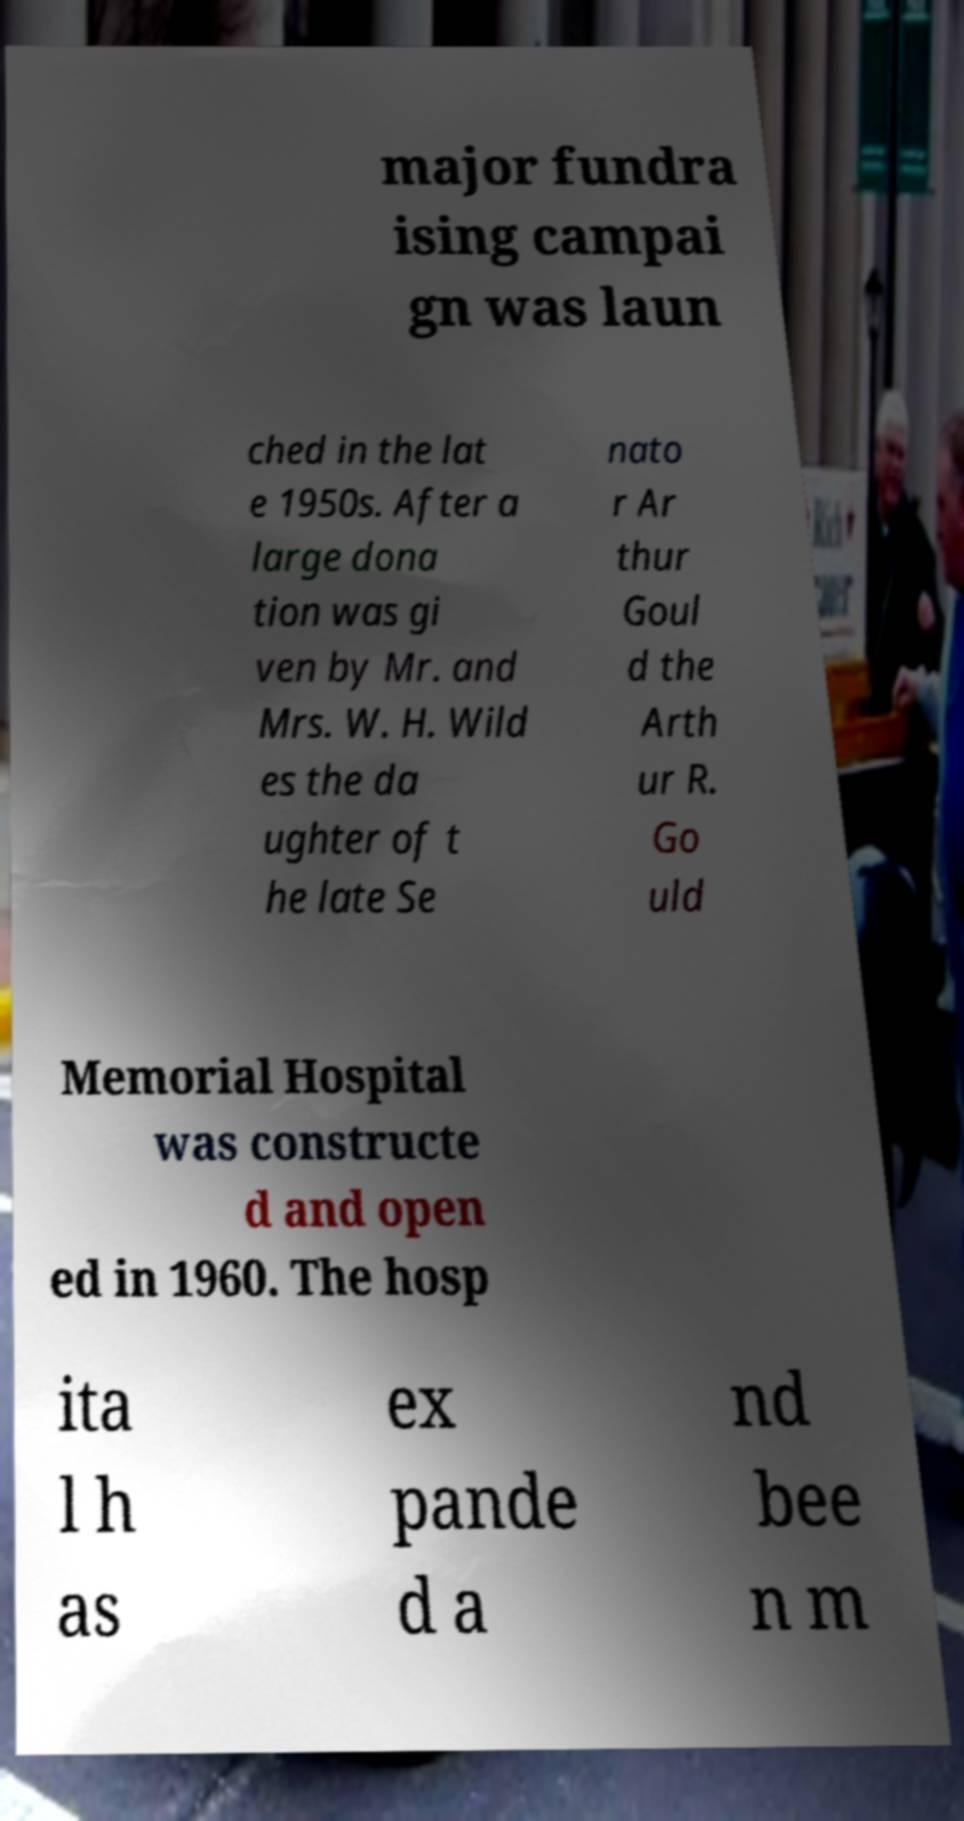What messages or text are displayed in this image? I need them in a readable, typed format. major fundra ising campai gn was laun ched in the lat e 1950s. After a large dona tion was gi ven by Mr. and Mrs. W. H. Wild es the da ughter of t he late Se nato r Ar thur Goul d the Arth ur R. Go uld Memorial Hospital was constructe d and open ed in 1960. The hosp ita l h as ex pande d a nd bee n m 